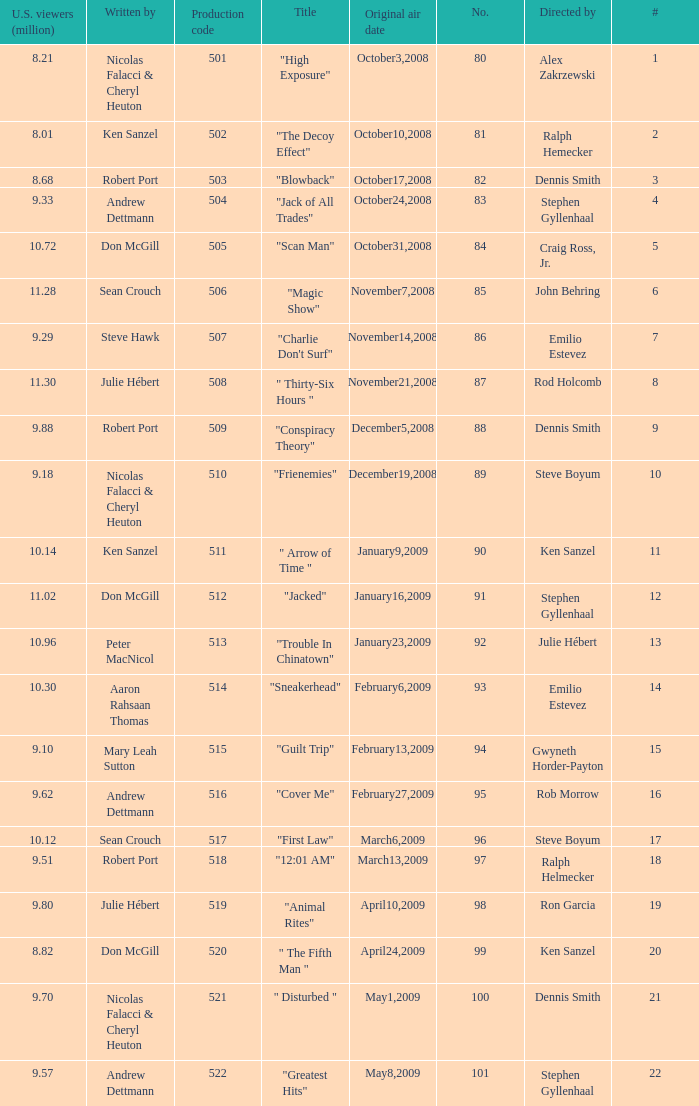Who wrote the episode with the production code 519? Julie Hébert. 